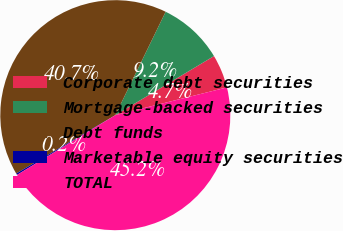Convert chart. <chart><loc_0><loc_0><loc_500><loc_500><pie_chart><fcel>Corporate debt securities<fcel>Mortgage-backed securities<fcel>Debt funds<fcel>Marketable equity securities<fcel>TOTAL<nl><fcel>4.71%<fcel>9.2%<fcel>40.68%<fcel>0.22%<fcel>45.18%<nl></chart> 